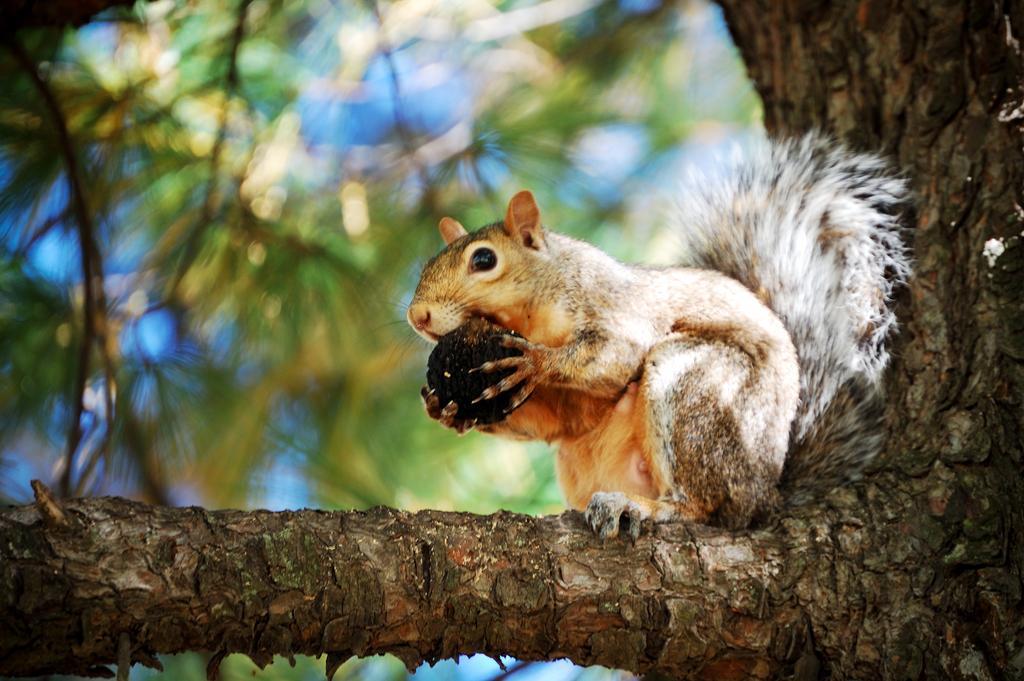Describe this image in one or two sentences. In the picture I can see a squirrel is holding a nut and sitting on a branch of a tree. The background of the image is blurred. 